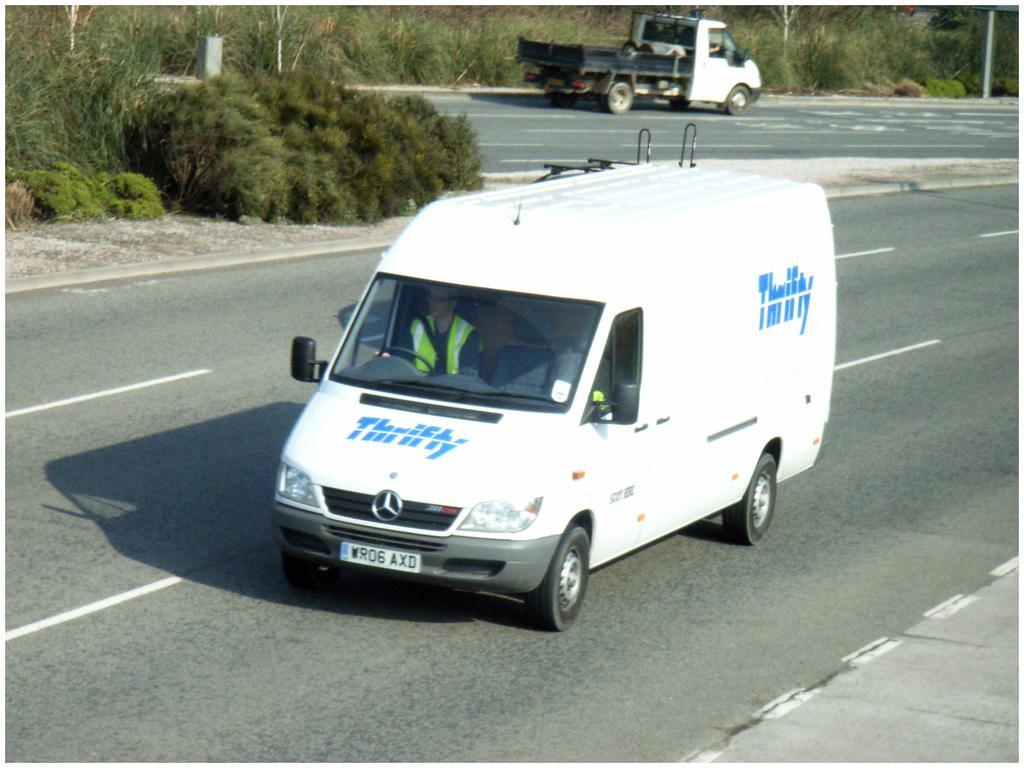Please provide a concise description of this image. Here in this picture we can see a white colored van present on the road and we can also see a person inside it and behind it also we can see a vehicle present and beside that we can see plants present on the ground. 